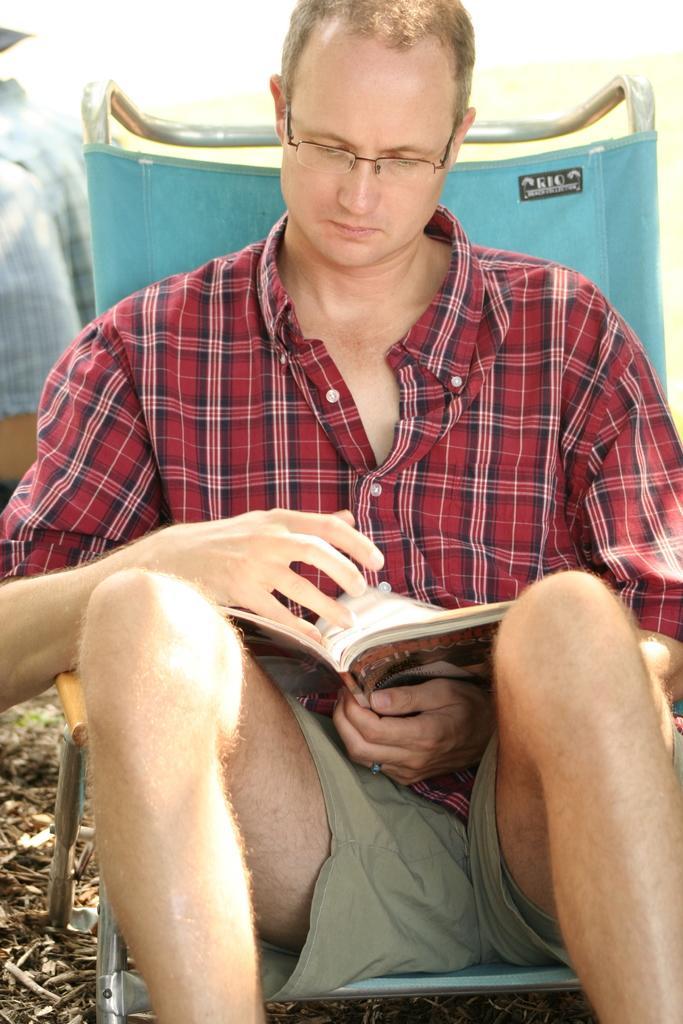Please provide a concise description of this image. In this image in the foreground there is one person who is sitting on a chair and he is holding a book and reading, at the bottom there is some scrap. 